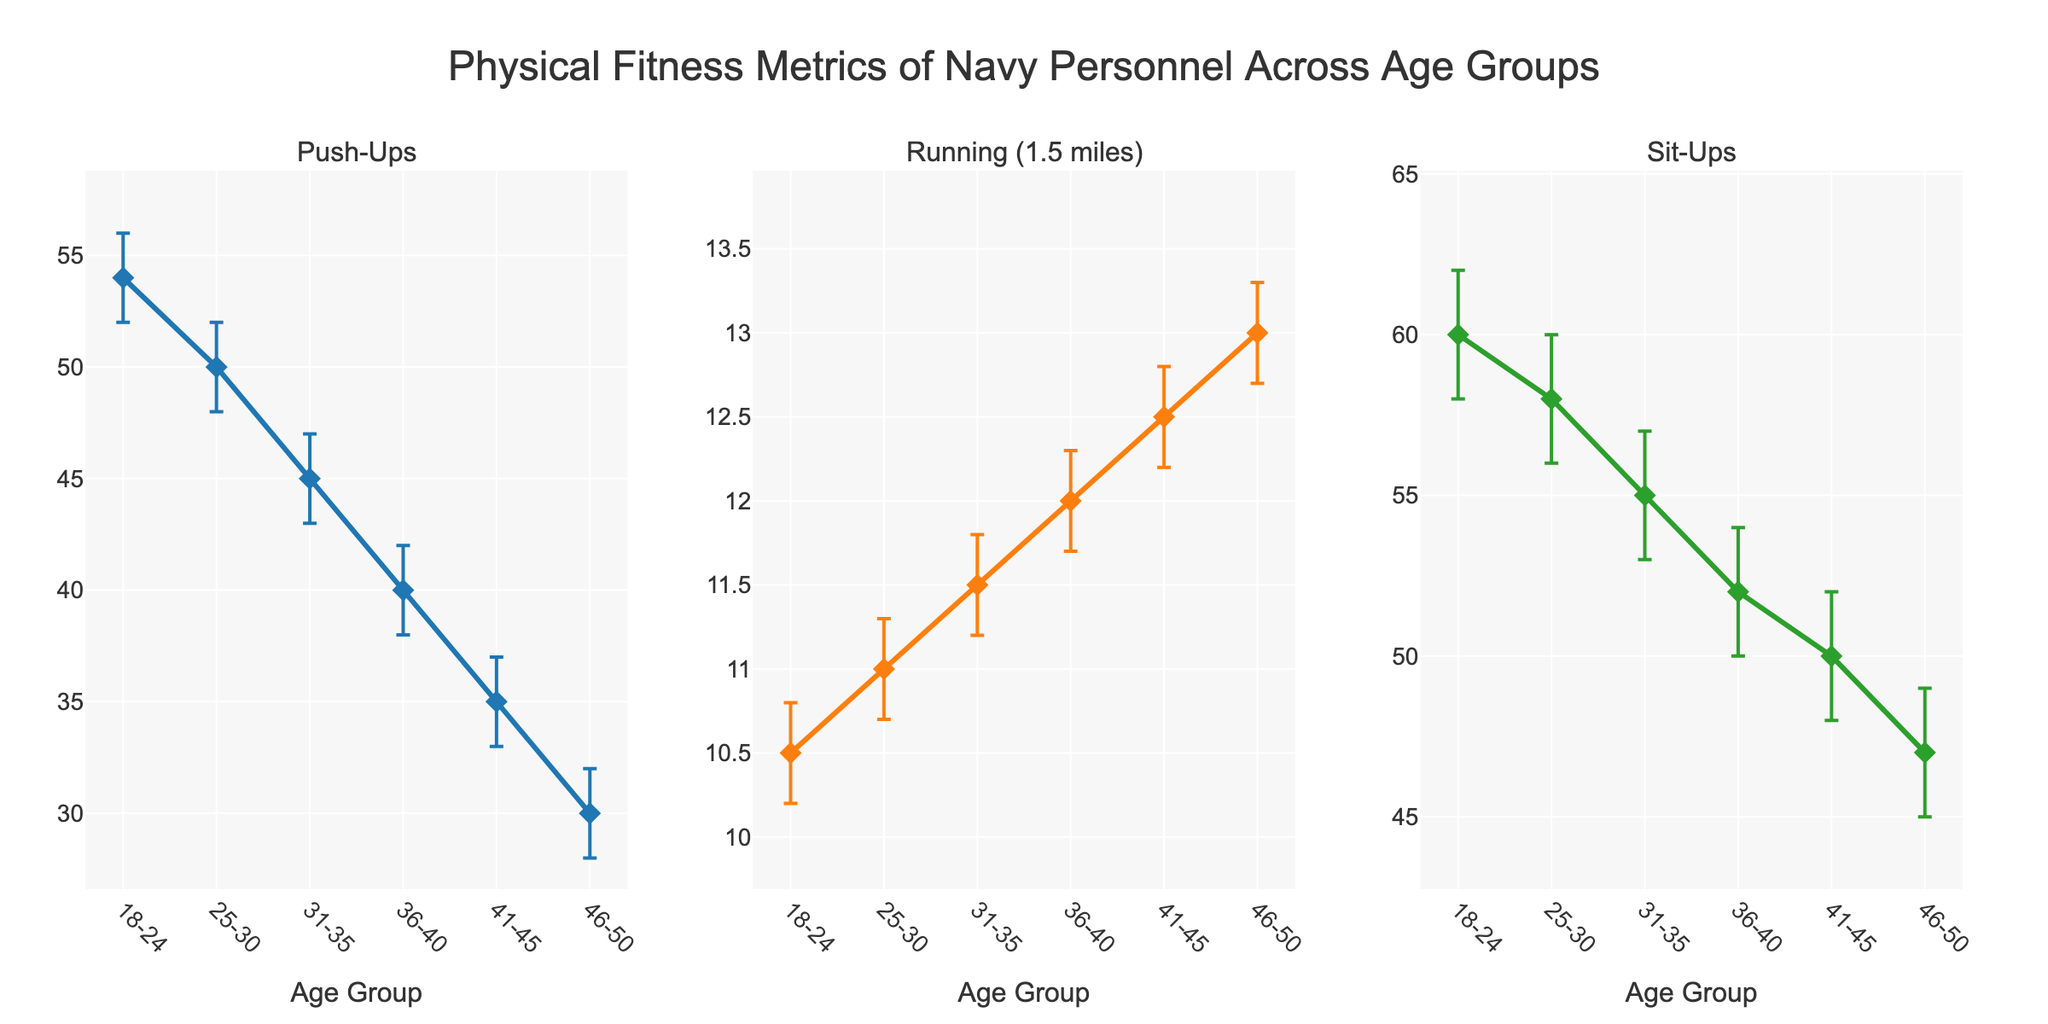Which age group has the highest mean number of push-ups? The plot shows the mean number of push-ups for each age group. The 18-24 age group has the highest mean value.
Answer: 18-24 How does the mean running time for a 1.5-mile run change as age increases? By observing the line plot for the running metric, it is clear that the mean running time increases as age increases.
Answer: Increases What is the confidence interval range for sit-ups in the 25-30 age group? The lower bound is 56, and the upper bound is 60. The range is 60 - 56 = 4.
Answer: 4 Compare the mean number of push-ups between the 18-24 and 31-35 age groups. From the push-ups line plot, the mean values are 54 for 18-24 and 45 for 31-35.
Answer: 54 and 45 What is the trend of sit-ups across different age groups? By looking at the sit-ups metric, the mean number of sit-ups decreases as the age groups get older.
Answer: Decreasing Which metric shows the greatest variability in its confidence intervals across all age groups? By comparing the size of the error bars in each subplot, the running (1.5 miles) metrics have the largest and most variable confidence intervals.
Answer: Running (1.5 miles) What is the difference in the upper 95% CI values for sit-ups between the 18-24 and 46-50 age groups? The upper 95% CI for sit-ups is 62 for 18-24 and 49 for 46-50. The difference is 62 - 49 = 13.
Answer: 13 Which age group shows the lowest mean value for the running (1.5 miles) metric? By examining the line plot for the running metric, the 18-24 age group has the lowest mean value.
Answer: 18-24 How does the mean number of push-ups differ between the 36-40 and the 46-50 age groups? From the push-ups plot, the mean values are 40 for 36-40 and 30 for 46-50. The difference is 40 - 30 = 10.
Answer: 10 